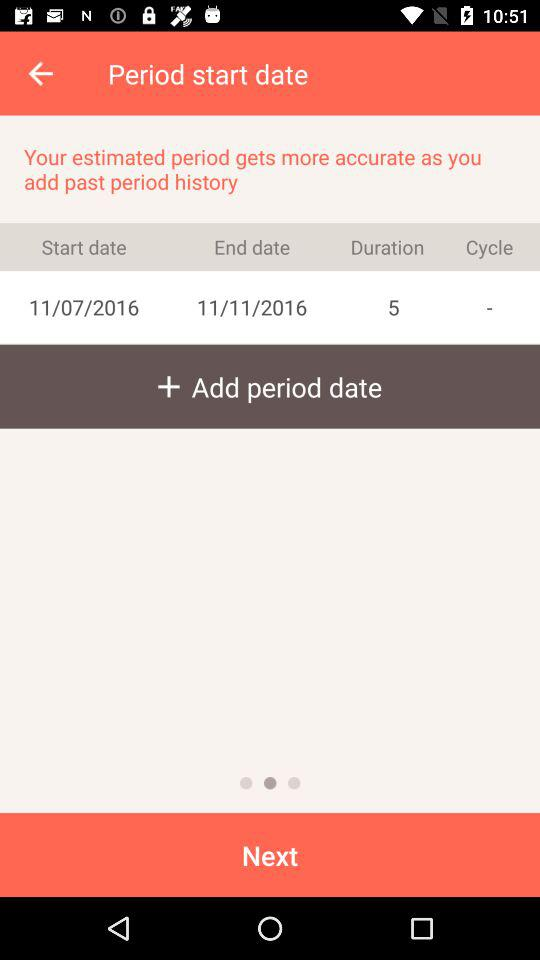How many days are in the cycle?
Answer the question using a single word or phrase. 5 